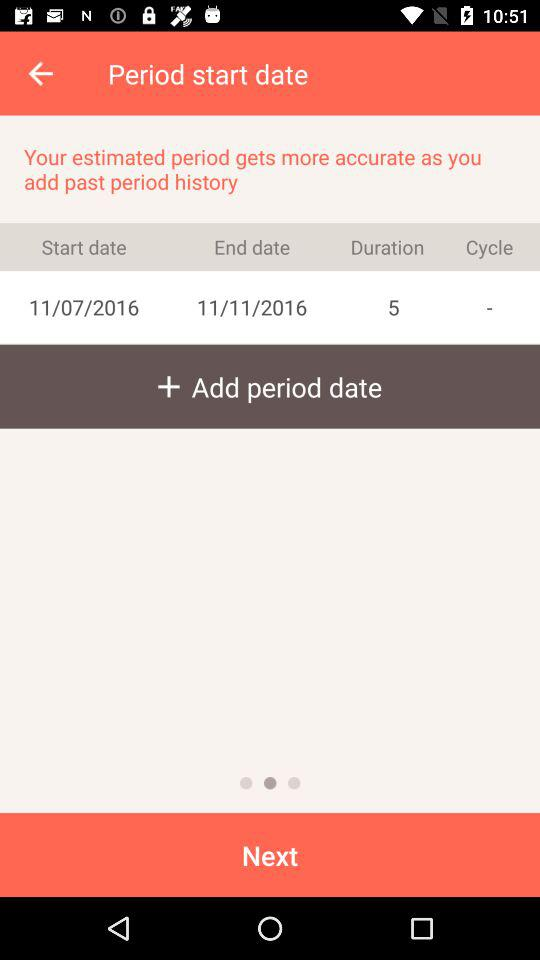How many days are in the cycle?
Answer the question using a single word or phrase. 5 